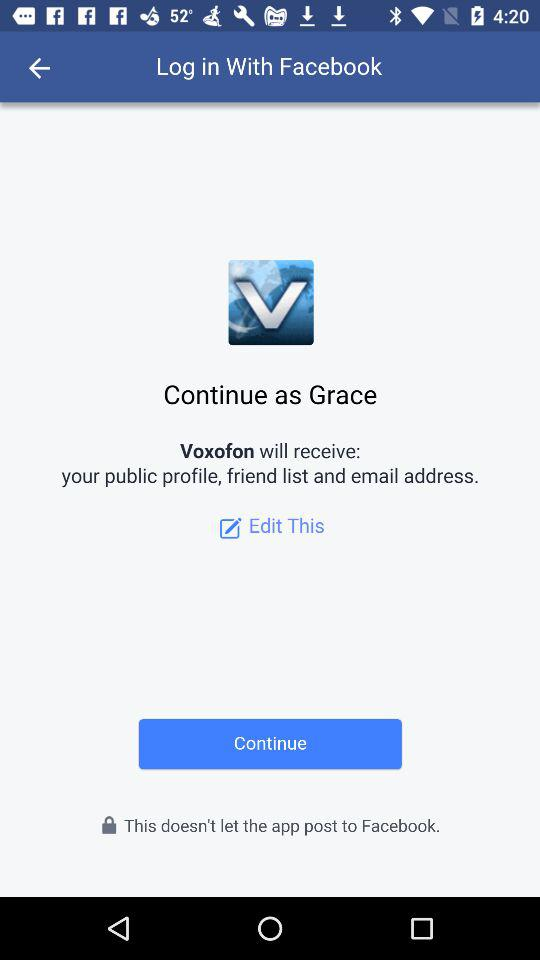What is the profile name? The profile name is Grace. 